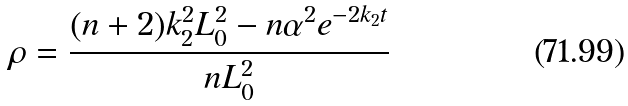<formula> <loc_0><loc_0><loc_500><loc_500>\rho = \frac { ( n + 2 ) k _ { 2 } ^ { 2 } L _ { 0 } ^ { 2 } - n \alpha ^ { 2 } e ^ { - 2 k _ { 2 } t } } { n L _ { 0 } ^ { 2 } }</formula> 